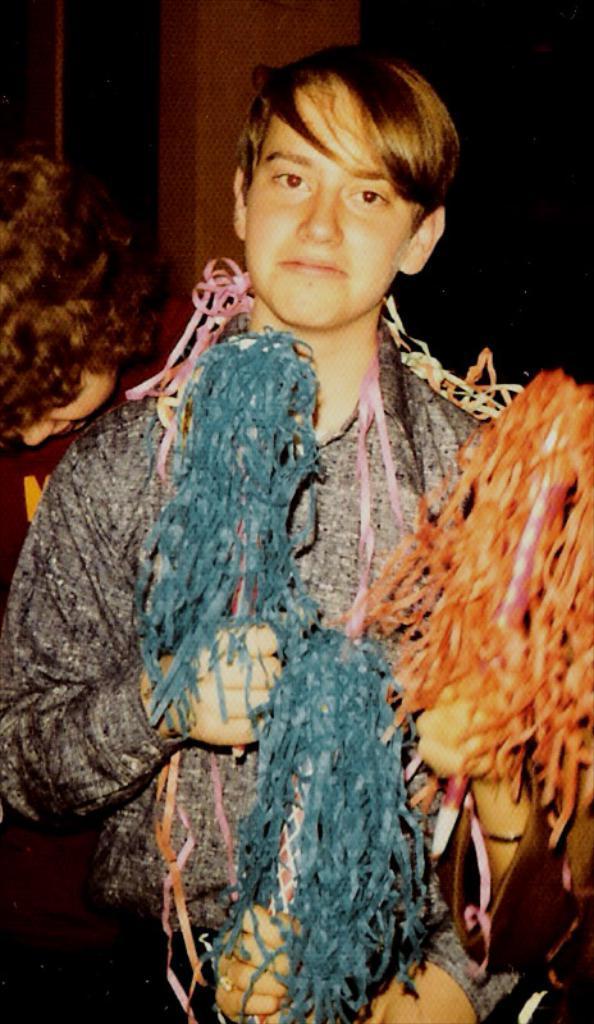Can you describe this image briefly? In the image there is a boy, he is holding some crafted items with his hand and behind the boy there is some other person holding another item and behind him there is another boy. 